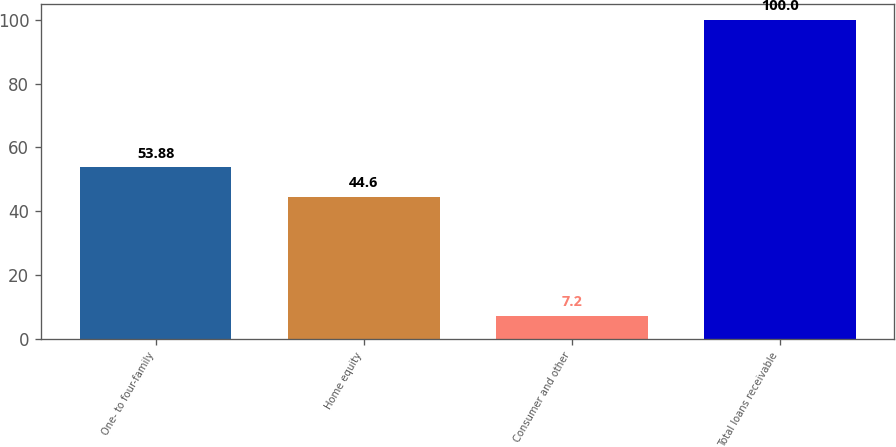<chart> <loc_0><loc_0><loc_500><loc_500><bar_chart><fcel>One- to four-family<fcel>Home equity<fcel>Consumer and other<fcel>Total loans receivable<nl><fcel>53.88<fcel>44.6<fcel>7.2<fcel>100<nl></chart> 